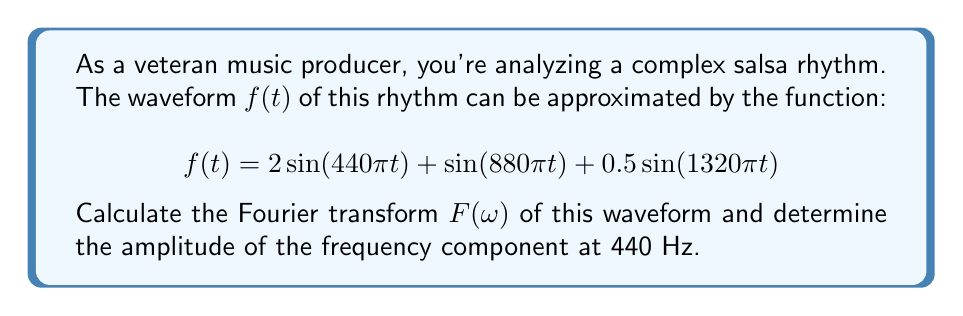Help me with this question. To solve this problem, we'll follow these steps:

1) The Fourier transform of a function $f(t)$ is given by:

   $$F(\omega) = \int_{-\infty}^{\infty} f(t) e^{-i\omega t} dt$$

2) For our waveform:

   $$f(t) = 2\sin(440\pi t) + \sin(880\pi t) + 0.5\sin(1320\pi t)$$

3) We can use the linearity property of Fourier transforms:

   $$\mathcal{F}\{af(t) + bg(t)\} = aF(\omega) + bG(\omega)$$

4) We also know that for a sine function:

   $$\mathcal{F}\{\sin(\omega_0 t)\} = \pi i [\delta(\omega + \omega_0) - \delta(\omega - \omega_0)]$$

5) Applying these to our waveform:

   $$F(\omega) = 2\pi i [2\delta(\omega + 440\pi) - 2\delta(\omega - 440\pi)]$$
   $$+ \pi i [\delta(\omega + 880\pi) - \delta(\omega - 880\pi)]$$
   $$+ 0.5\pi i [\delta(\omega + 1320\pi) - \delta(\omega - 1320\pi)]$$

6) The amplitude of a frequency component is given by the magnitude of its coefficient in the Fourier transform.

7) For the 440 Hz component (which corresponds to $\omega = 440\pi$), the coefficient is $-2\pi i \cdot 2 = -4\pi i$.

8) The magnitude of this coefficient is $|-4\pi i| = 4\pi$.

Therefore, the amplitude of the 440 Hz component is $4\pi$.
Answer: $4\pi$ 